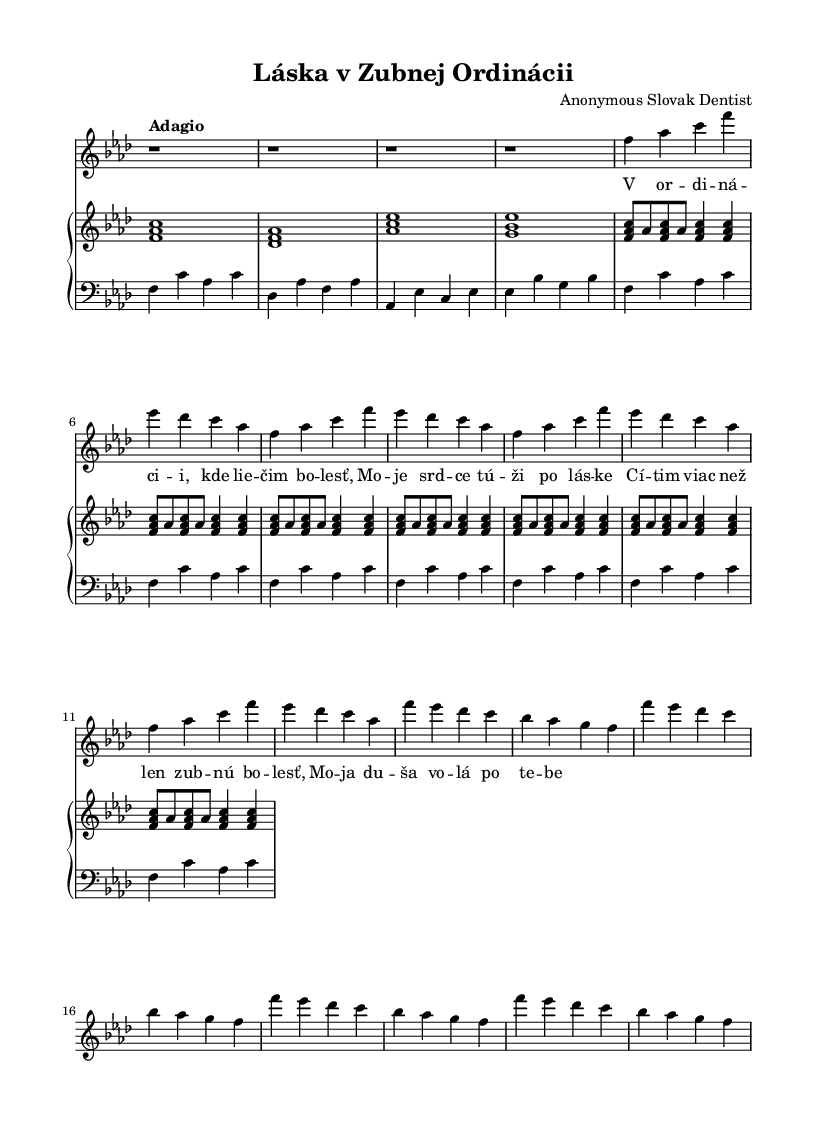What is the key signature of this music? The key signature is indicated at the beginning of the score and shows four flats. This corresponds to the key of F minor.
Answer: F minor What is the time signature of this music? The time signature is displayed as a fraction at the beginning; it shows a 4 above a 4, which means there are four beats per measure with the quarter note getting one beat.
Answer: 4/4 What tempo marking is indicated for this piece? The tempo marking is shown on the score, stating "Adagio", meaning the piece should be played slowly.
Answer: Adagio How many measures are in the first verse? By counting the segments of music notation, the first verse consists of eight measures. This can be verified by identifying each bar line that separates the measures.
Answer: 8 What emotions are conveyed in the lyrics of the chorus? The lyrics describe a longing and emotional pain related to love, emphasizing a deeper feeling beyond just physical discomfort. This reflects the intense emotional experiences characteristic of Romantic music.
Answer: Longing What is the dynamic indication for the soprano part? The dynamic marking is placed above the soprano staff, which is "Up", indicating that the singer should perform with a bright and strong sound.
Answer: Dynamic Up How is the structure of the piece organized? The piece begins with an introduction, followed by a verse and a chorus, which is a typical structure in Romantic operatic arias focused on expressing inner feelings and relationships.
Answer: Introduction, Verse, Chorus 